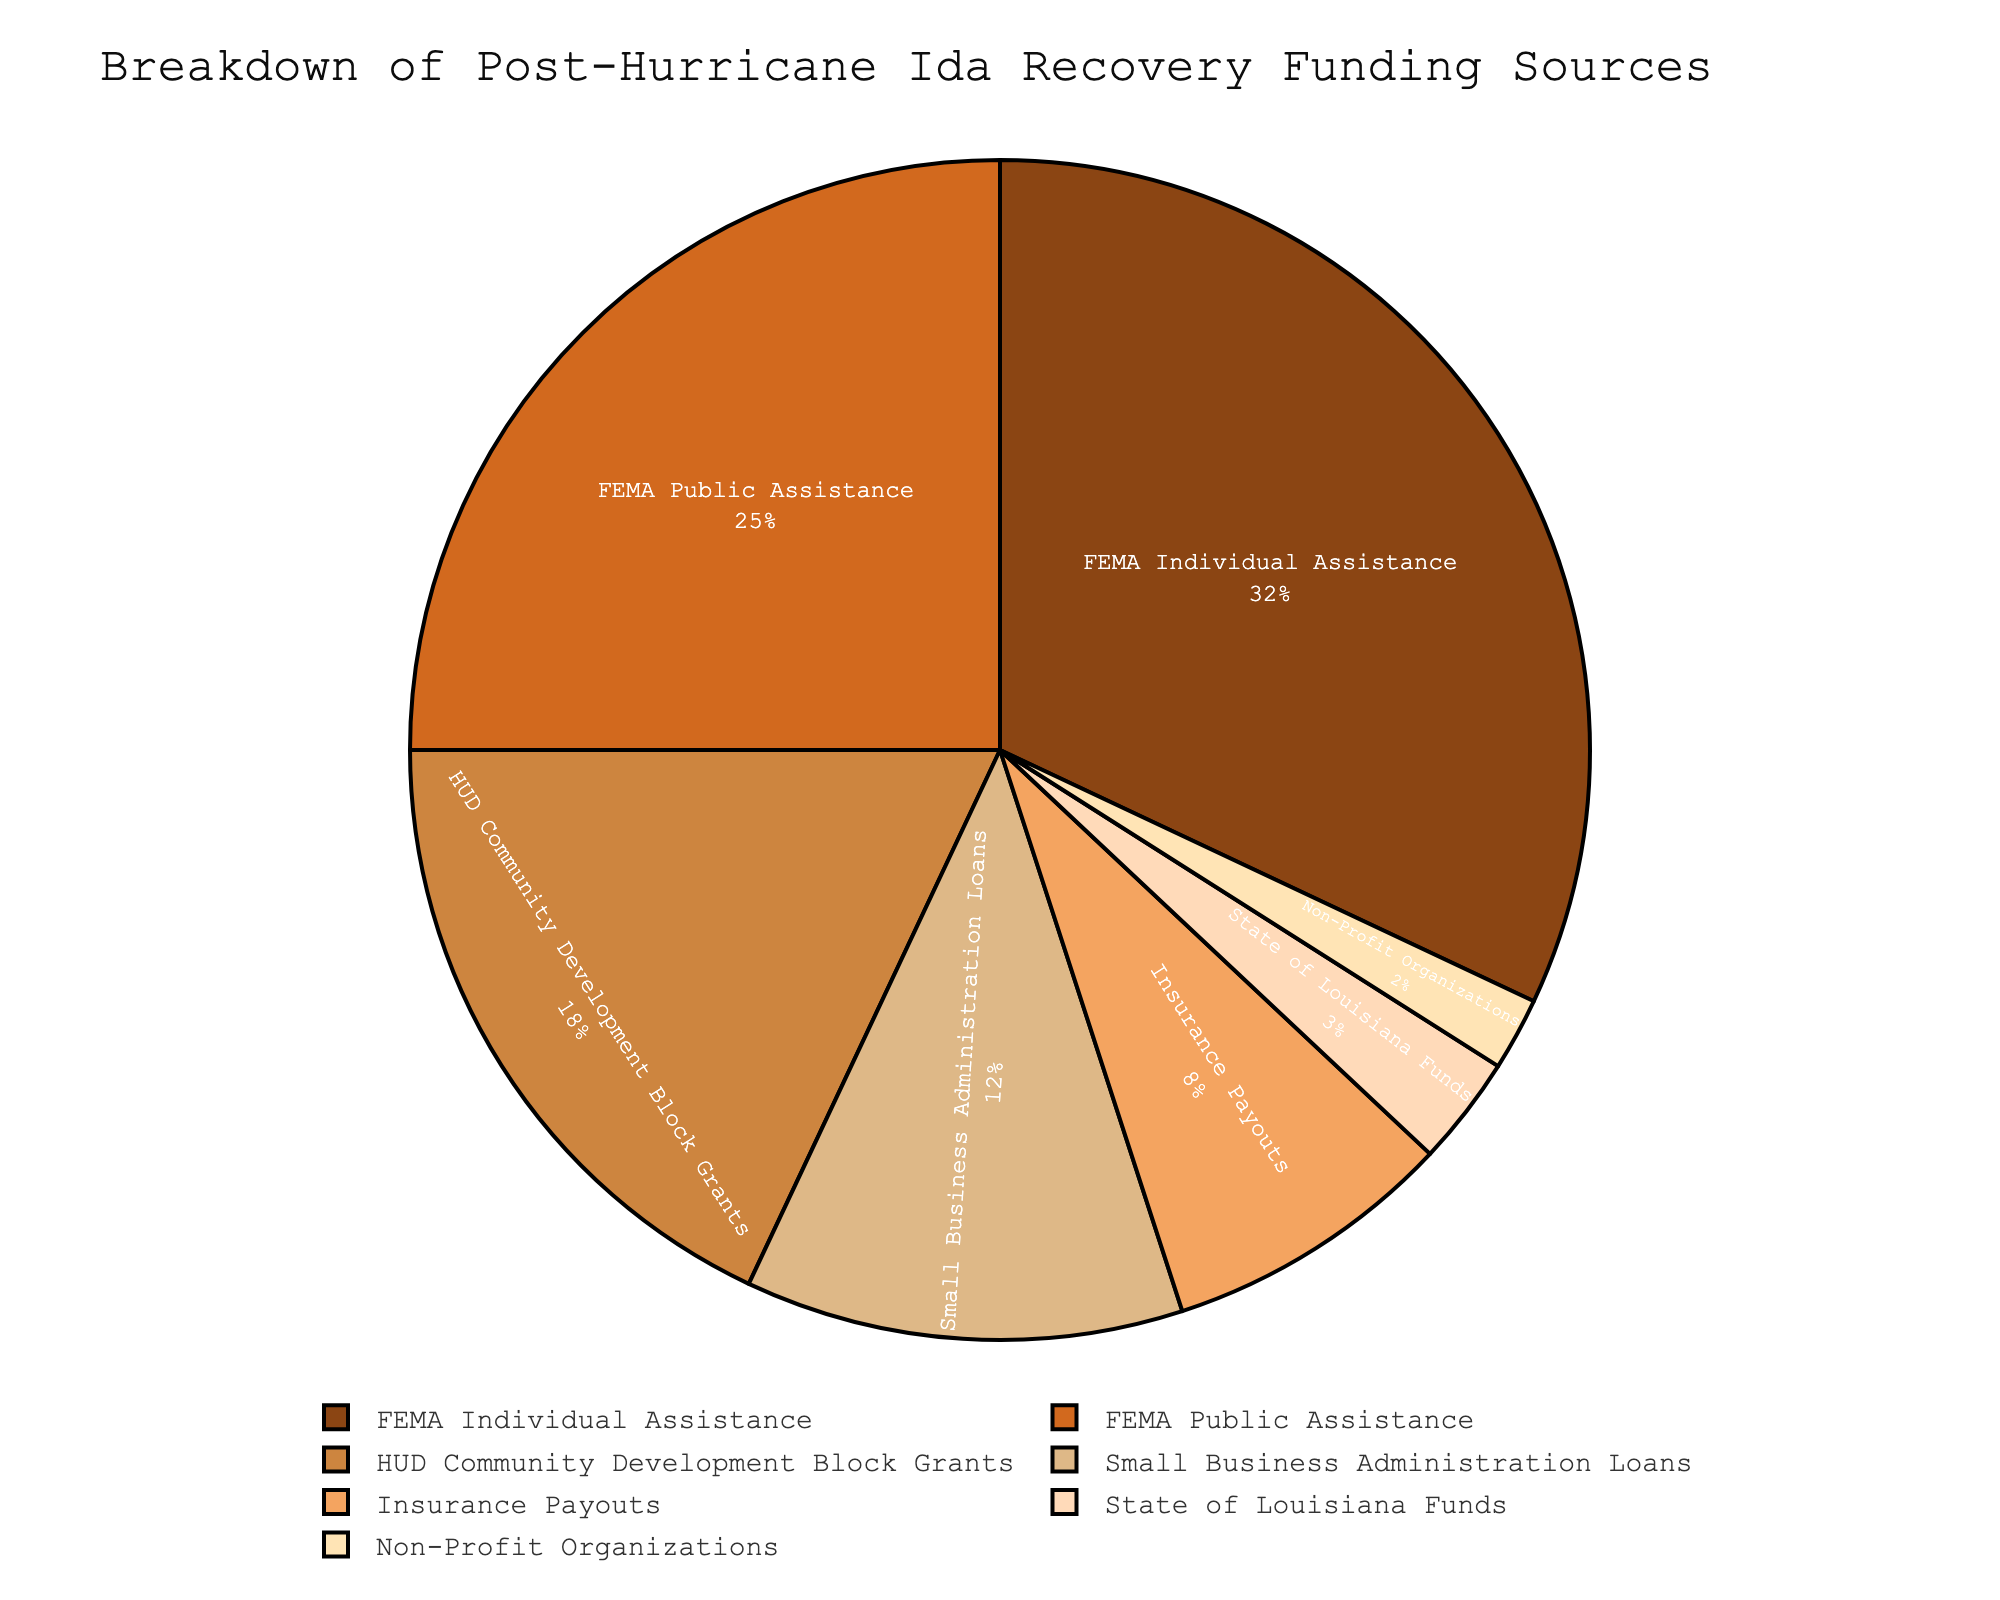What is the largest funding source for post-Hurricane Ida recovery? The largest funding source can be identified by the highest percentage in the pie chart. Here, 'FEMA Individual Assistance' has the highest percentage at 32%.
Answer: FEMA Individual Assistance Which funding source contributes less than 5% to the recovery efforts? By looking at the segments of the pie chart and their associated percentages, 'Non-Profit Organizations' contributes 2%, which is less than 5%.
Answer: Non-Profit Organizations What is the combined percentage of FEMA Public Assistance and HUD Community Development Block Grants? Sum the percentages of 'FEMA Public Assistance' and 'HUD Community Development Block Grants'. That is 25% + 18% = 43%.
Answer: 43% How does the percentage of Small Business Administration Loans compare to Insurance Payouts? Compare the percentages from the pie chart: 'Small Business Administration Loans' is 12%, and 'Insurance Payouts' is 8%. Therefore, SBA Loans are higher.
Answer: Small Business Administration Loans is higher What is the difference in percentage between FEMA Individual Assistance and State of Louisiana Funds? Subtract the percentage of 'State of Louisiana Funds' from 'FEMA Individual Assistance': 32% - 3% = 29%.
Answer: 29% Which segments of the pie chart are adjacent in color to HUD Community Development Block Grants? The segments adjacent in color to 'HUD Community Development Block Grants' would be the ones following or preceding its colored segment. According to the custom color palette provided, HUD is surrounded by 'FEMA Public Assistance' and 'Small Business Administration Loans'.
Answer: FEMA Public Assistance and Small Business Administration Loans What is the total percentage contributed by non-governmental sources? Sum the percentages of 'Small Business Administration Loans', 'Insurance Payouts', and 'Non-Profit Organizations': 12% + 8% + 2% = 22%.
Answer: 22% Which funding sources are greater than 10% but less than 30%? Identify the segments with percentages in this range: 'FEMA Public Assistance' at 25%, 'HUD Community Development Block Grants' at 18%, and 'Small Business Administration Loans' at 12%.
Answer: FEMA Public Assistance, HUD Community Development Block Grants, Small Business Administration Loans What funding source has a visually distinguishable color representing around 3%? In the pie chart with the given custom colors, the segment representing around 3% is 'State of Louisiana Funds'.
Answer: State of Louisiana Funds 